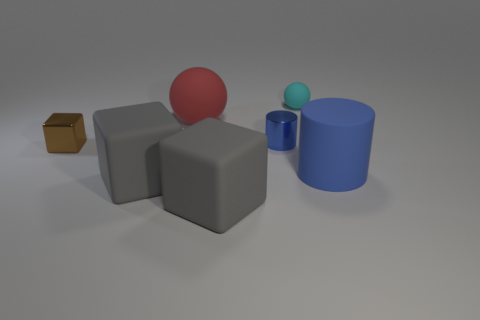Add 2 shiny things. How many objects exist? 9 Subtract all cylinders. How many objects are left? 5 Subtract all big blue matte cylinders. Subtract all small blue shiny things. How many objects are left? 5 Add 3 red rubber objects. How many red rubber objects are left? 4 Add 7 gray metallic cubes. How many gray metallic cubes exist? 7 Subtract 0 gray balls. How many objects are left? 7 